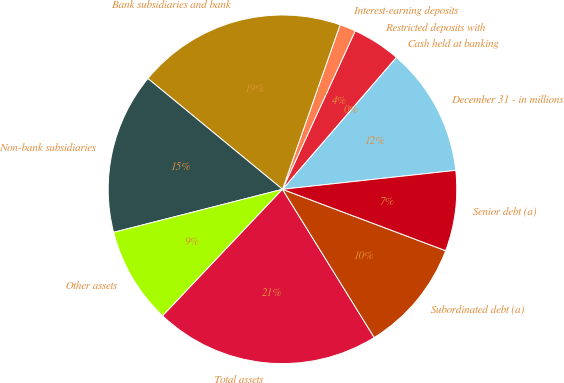Convert chart to OTSL. <chart><loc_0><loc_0><loc_500><loc_500><pie_chart><fcel>December 31 - in millions<fcel>Cash held at banking<fcel>Restricted deposits with<fcel>Interest-earning deposits<fcel>Bank subsidiaries and bank<fcel>Non-bank subsidiaries<fcel>Other assets<fcel>Total assets<fcel>Subordinated debt (a)<fcel>Senior debt (a)<nl><fcel>11.94%<fcel>0.0%<fcel>4.48%<fcel>1.49%<fcel>19.4%<fcel>14.93%<fcel>8.96%<fcel>20.89%<fcel>10.45%<fcel>7.46%<nl></chart> 